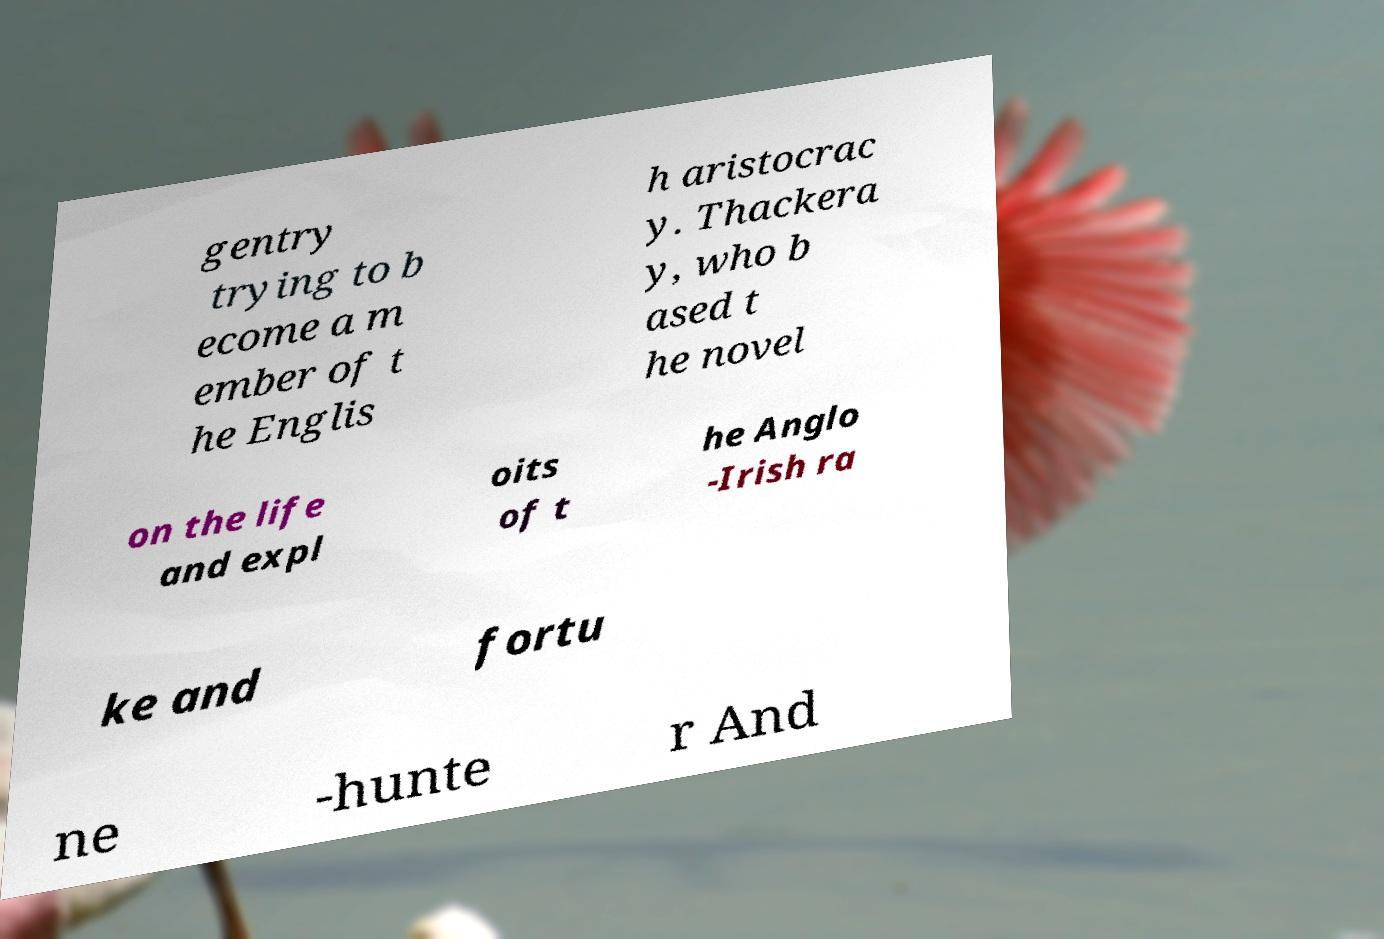Please read and relay the text visible in this image. What does it say? gentry trying to b ecome a m ember of t he Englis h aristocrac y. Thackera y, who b ased t he novel on the life and expl oits of t he Anglo -Irish ra ke and fortu ne -hunte r And 